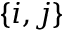Convert formula to latex. <formula><loc_0><loc_0><loc_500><loc_500>\{ i , j \}</formula> 